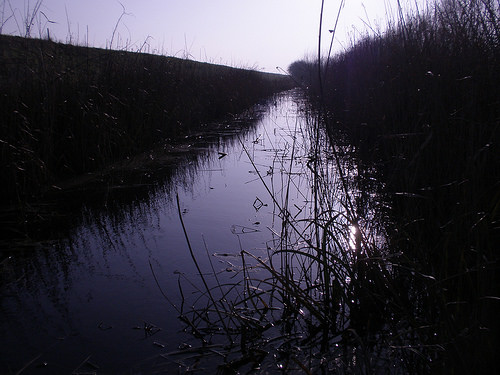<image>
Can you confirm if the river is next to the plant? Yes. The river is positioned adjacent to the plant, located nearby in the same general area. 